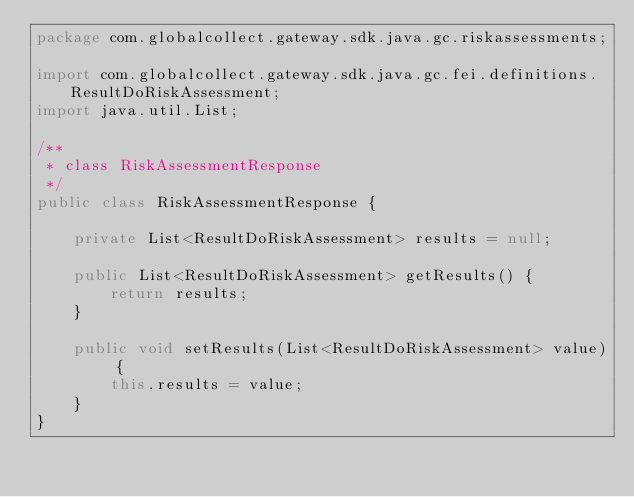<code> <loc_0><loc_0><loc_500><loc_500><_Java_>package com.globalcollect.gateway.sdk.java.gc.riskassessments;

import com.globalcollect.gateway.sdk.java.gc.fei.definitions.ResultDoRiskAssessment;
import java.util.List;

/**
 * class RiskAssessmentResponse
 */
public class RiskAssessmentResponse {

	private List<ResultDoRiskAssessment> results = null;

	public List<ResultDoRiskAssessment> getResults() {
		return results;
	}

	public void setResults(List<ResultDoRiskAssessment> value) {
		this.results = value;
	}
}
</code> 